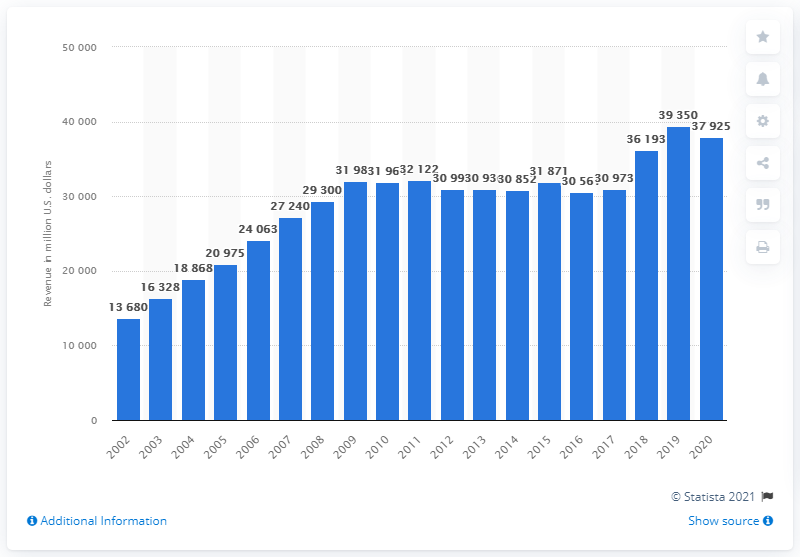Draw attention to some important aspects in this diagram. In 2020, the revenue of General Dynamics was 37,925. 